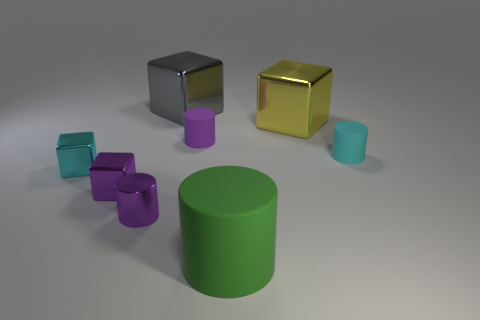How many objects are either tiny matte cylinders behind the tiny cyan rubber thing or tiny purple shiny things? In the image, we have exactly two tiny purple shiny objects and one tiny matte cylinder located behind the larger cyan cylinder. So, the total number of objects that either fit the criteria of being tiny matte cylinders behind the tiny cyan rubber thing or tiny purple shiny things is three. 